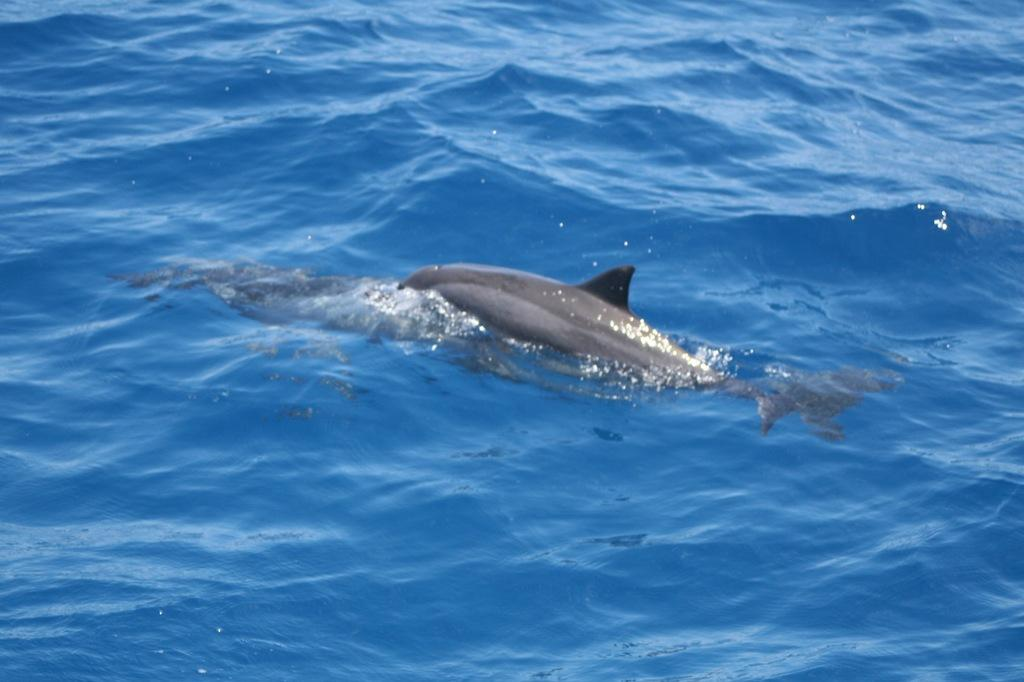What type of animals can be seen in the water in the image? There are fishes in the water. Can you describe the environment in which the fishes are located? The fishes are located in water. What type of pizzas can be seen floating in the water in the image? There are no pizzas present in the image; it features fishes in the water. What color is the chalk used to draw on the zebra in the image? There is no zebra or chalk present in the image. 